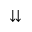<formula> <loc_0><loc_0><loc_500><loc_500>\downdownarrows</formula> 